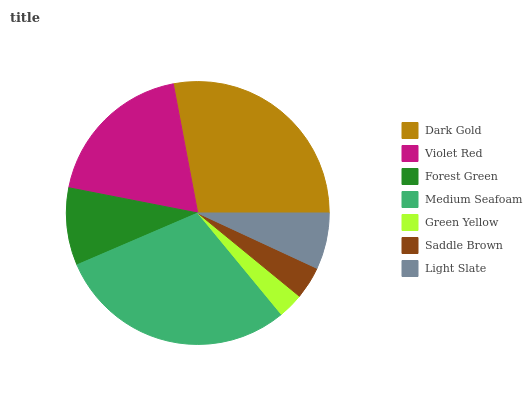Is Green Yellow the minimum?
Answer yes or no. Yes. Is Medium Seafoam the maximum?
Answer yes or no. Yes. Is Violet Red the minimum?
Answer yes or no. No. Is Violet Red the maximum?
Answer yes or no. No. Is Dark Gold greater than Violet Red?
Answer yes or no. Yes. Is Violet Red less than Dark Gold?
Answer yes or no. Yes. Is Violet Red greater than Dark Gold?
Answer yes or no. No. Is Dark Gold less than Violet Red?
Answer yes or no. No. Is Forest Green the high median?
Answer yes or no. Yes. Is Forest Green the low median?
Answer yes or no. Yes. Is Dark Gold the high median?
Answer yes or no. No. Is Violet Red the low median?
Answer yes or no. No. 